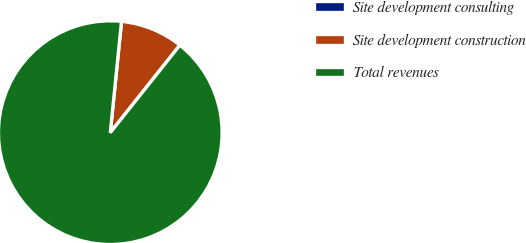Convert chart to OTSL. <chart><loc_0><loc_0><loc_500><loc_500><pie_chart><fcel>Site development consulting<fcel>Site development construction<fcel>Total revenues<nl><fcel>0.0%<fcel>9.09%<fcel>90.91%<nl></chart> 